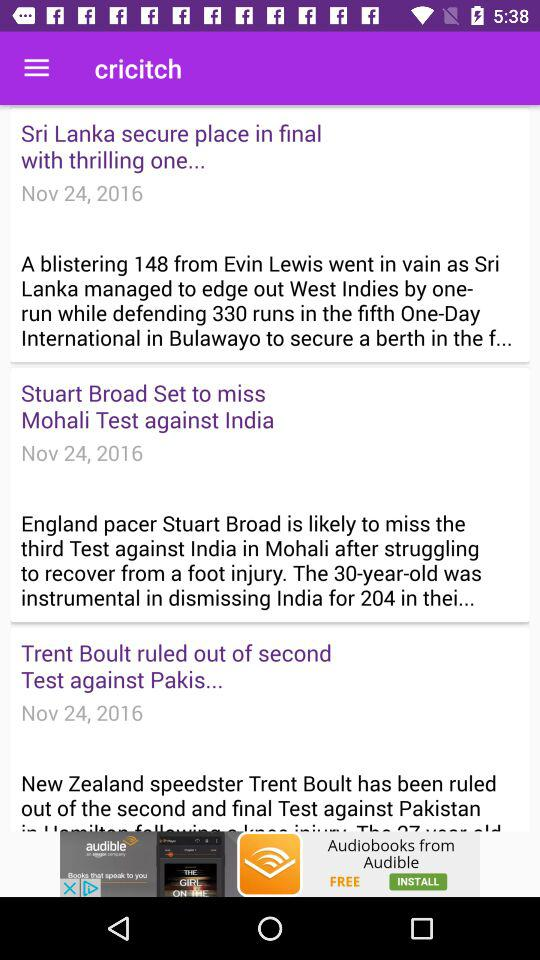What is the venue of the "South Africa" and "Australia" match? The venue is Adelaide Oval in Adelaide. 